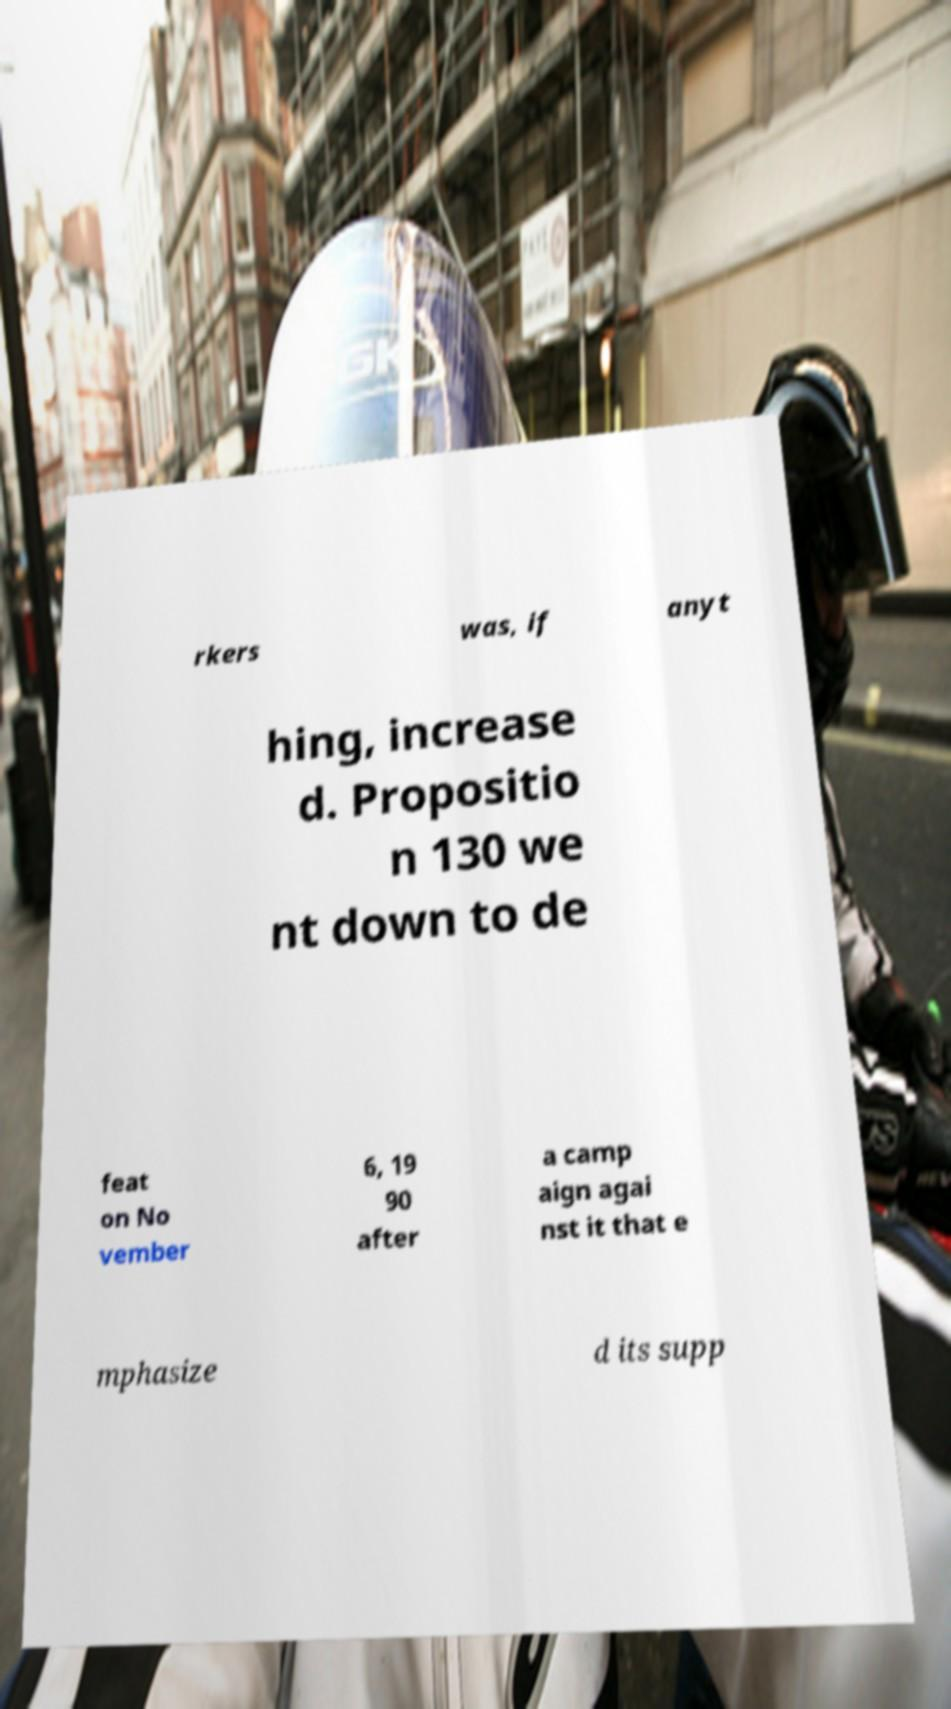There's text embedded in this image that I need extracted. Can you transcribe it verbatim? rkers was, if anyt hing, increase d. Propositio n 130 we nt down to de feat on No vember 6, 19 90 after a camp aign agai nst it that e mphasize d its supp 